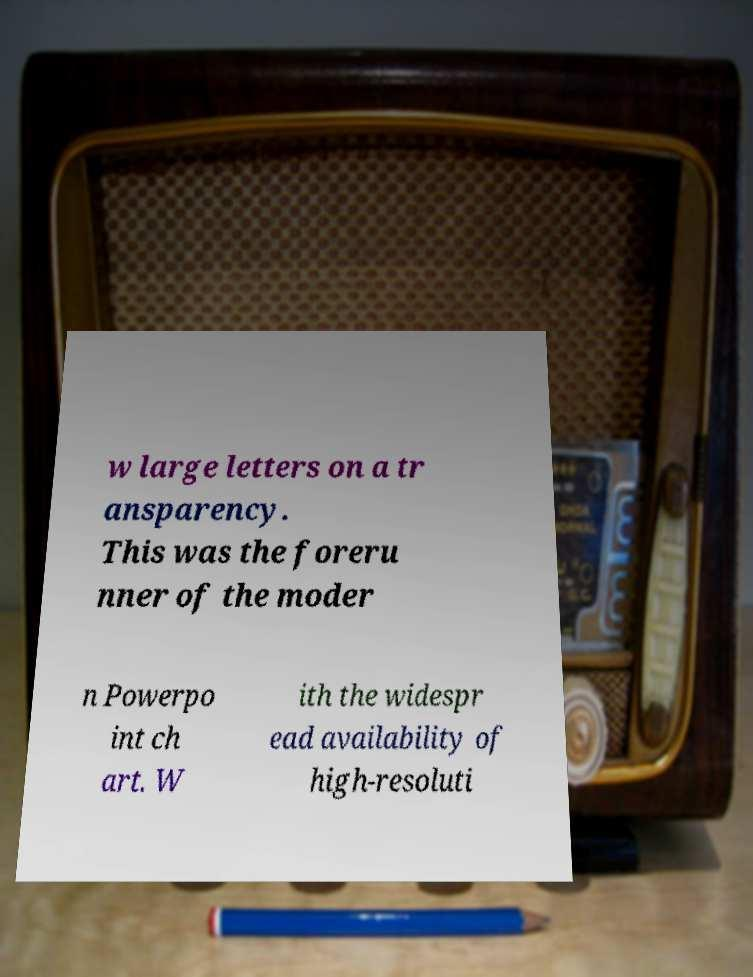Please read and relay the text visible in this image. What does it say? w large letters on a tr ansparency. This was the foreru nner of the moder n Powerpo int ch art. W ith the widespr ead availability of high-resoluti 